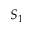Convert formula to latex. <formula><loc_0><loc_0><loc_500><loc_500>S _ { 1 }</formula> 